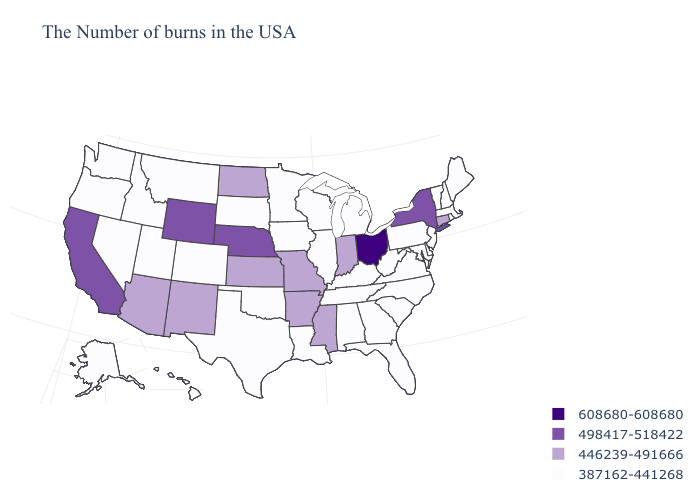What is the highest value in the USA?
Write a very short answer. 608680-608680. What is the value of Connecticut?
Write a very short answer. 446239-491666. Name the states that have a value in the range 498417-518422?
Quick response, please. New York, Nebraska, Wyoming, California. Does Washington have the highest value in the USA?
Give a very brief answer. No. Does the first symbol in the legend represent the smallest category?
Give a very brief answer. No. What is the value of Georgia?
Keep it brief. 387162-441268. Which states have the lowest value in the South?
Give a very brief answer. Delaware, Maryland, Virginia, North Carolina, South Carolina, West Virginia, Florida, Georgia, Kentucky, Alabama, Tennessee, Louisiana, Oklahoma, Texas. Does Arkansas have the highest value in the South?
Concise answer only. Yes. What is the value of Ohio?
Keep it brief. 608680-608680. Name the states that have a value in the range 387162-441268?
Keep it brief. Maine, Massachusetts, Rhode Island, New Hampshire, Vermont, New Jersey, Delaware, Maryland, Pennsylvania, Virginia, North Carolina, South Carolina, West Virginia, Florida, Georgia, Michigan, Kentucky, Alabama, Tennessee, Wisconsin, Illinois, Louisiana, Minnesota, Iowa, Oklahoma, Texas, South Dakota, Colorado, Utah, Montana, Idaho, Nevada, Washington, Oregon, Alaska, Hawaii. Does South Dakota have the same value as New Mexico?
Answer briefly. No. Does Massachusetts have the lowest value in the USA?
Give a very brief answer. Yes. What is the lowest value in states that border New Mexico?
Be succinct. 387162-441268. What is the value of Texas?
Write a very short answer. 387162-441268. Does Connecticut have the same value as Wisconsin?
Short answer required. No. 